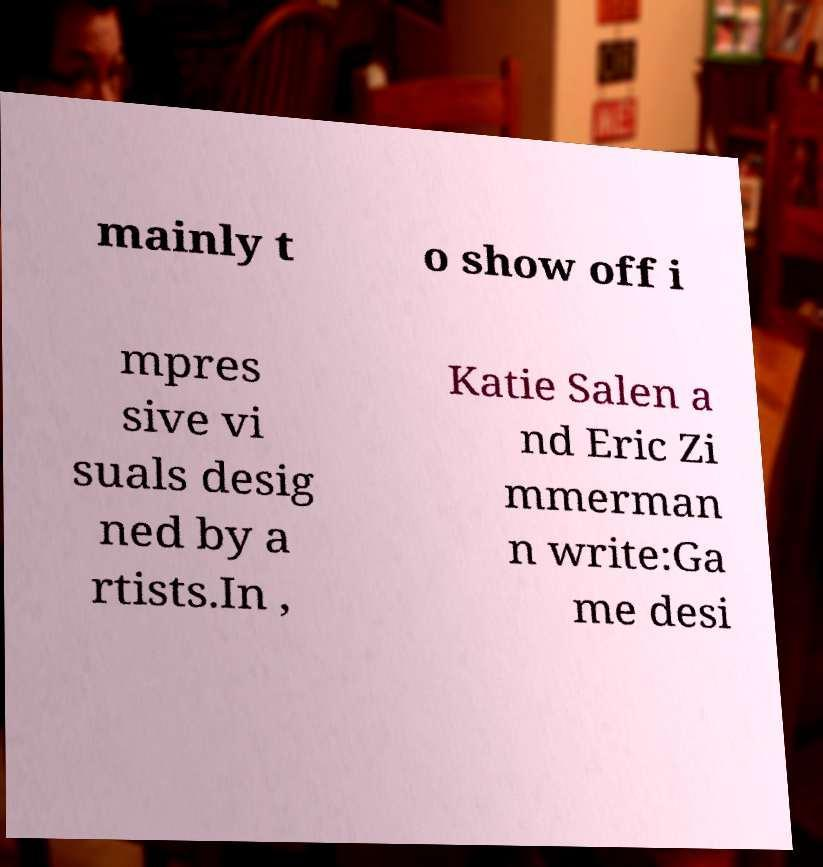There's text embedded in this image that I need extracted. Can you transcribe it verbatim? mainly t o show off i mpres sive vi suals desig ned by a rtists.In , Katie Salen a nd Eric Zi mmerman n write:Ga me desi 